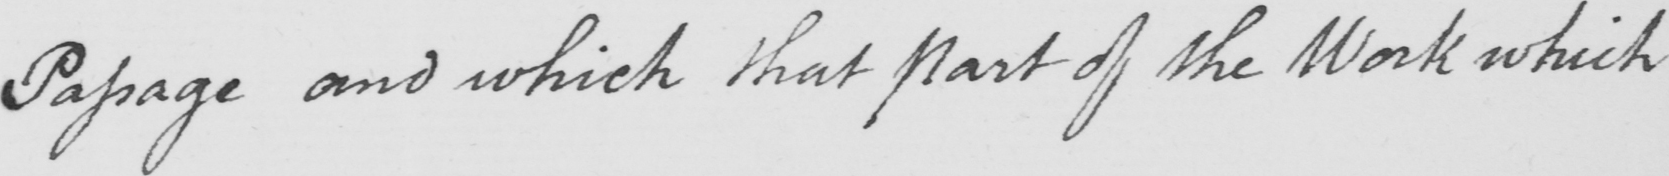What text is written in this handwritten line? Passage and which that part of the Work which 